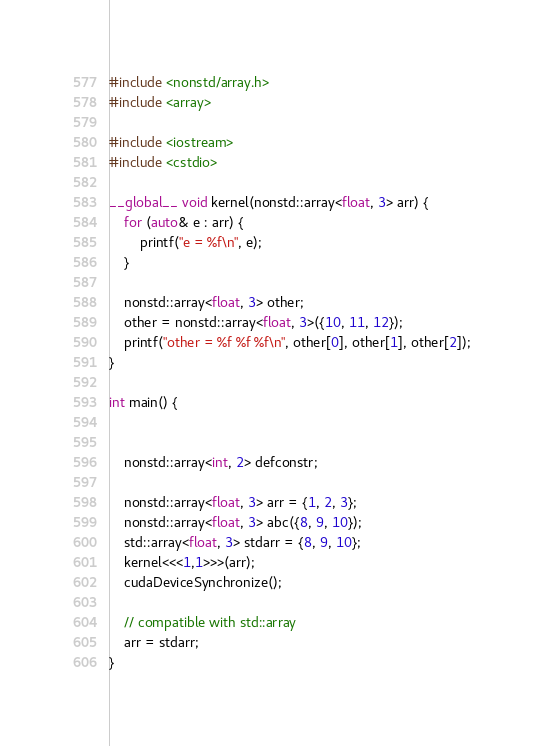<code> <loc_0><loc_0><loc_500><loc_500><_Cuda_>#include <nonstd/array.h>
#include <array>

#include <iostream>
#include <cstdio>

__global__ void kernel(nonstd::array<float, 3> arr) {
	for (auto& e : arr) {
		printf("e = %f\n", e);
	}

	nonstd::array<float, 3> other;
	other = nonstd::array<float, 3>({10, 11, 12});
	printf("other = %f %f %f\n", other[0], other[1], other[2]);
}

int main() {


	nonstd::array<int, 2> defconstr;

	nonstd::array<float, 3> arr = {1, 2, 3};
	nonstd::array<float, 3> abc({8, 9, 10});
	std::array<float, 3> stdarr = {8, 9, 10};
	kernel<<<1,1>>>(arr);
	cudaDeviceSynchronize();

	// compatible with std::array
	arr = stdarr;
}
</code> 